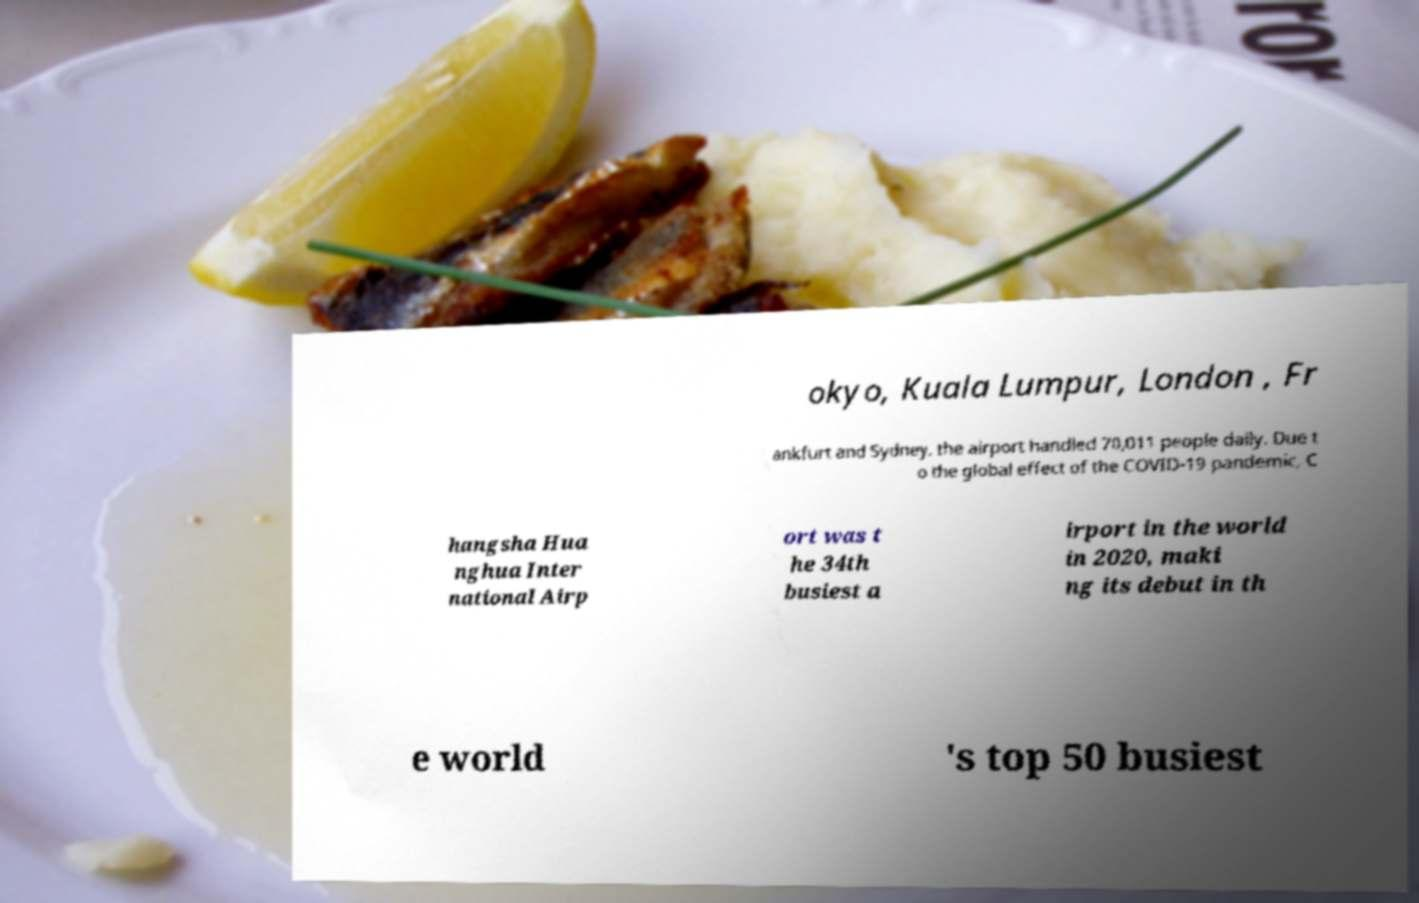Could you assist in decoding the text presented in this image and type it out clearly? okyo, Kuala Lumpur, London , Fr ankfurt and Sydney. the airport handled 70,011 people daily. Due t o the global effect of the COVID-19 pandemic, C hangsha Hua nghua Inter national Airp ort was t he 34th busiest a irport in the world in 2020, maki ng its debut in th e world 's top 50 busiest 